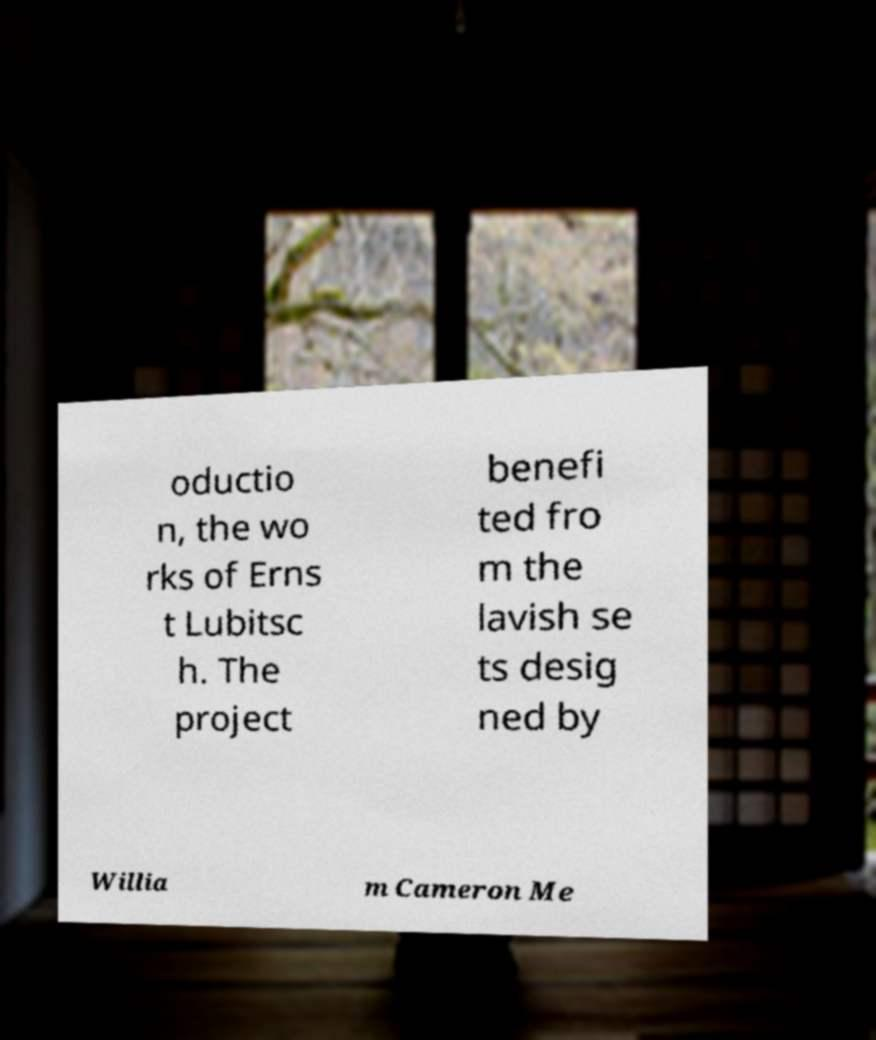Please read and relay the text visible in this image. What does it say? oductio n, the wo rks of Erns t Lubitsc h. The project benefi ted fro m the lavish se ts desig ned by Willia m Cameron Me 